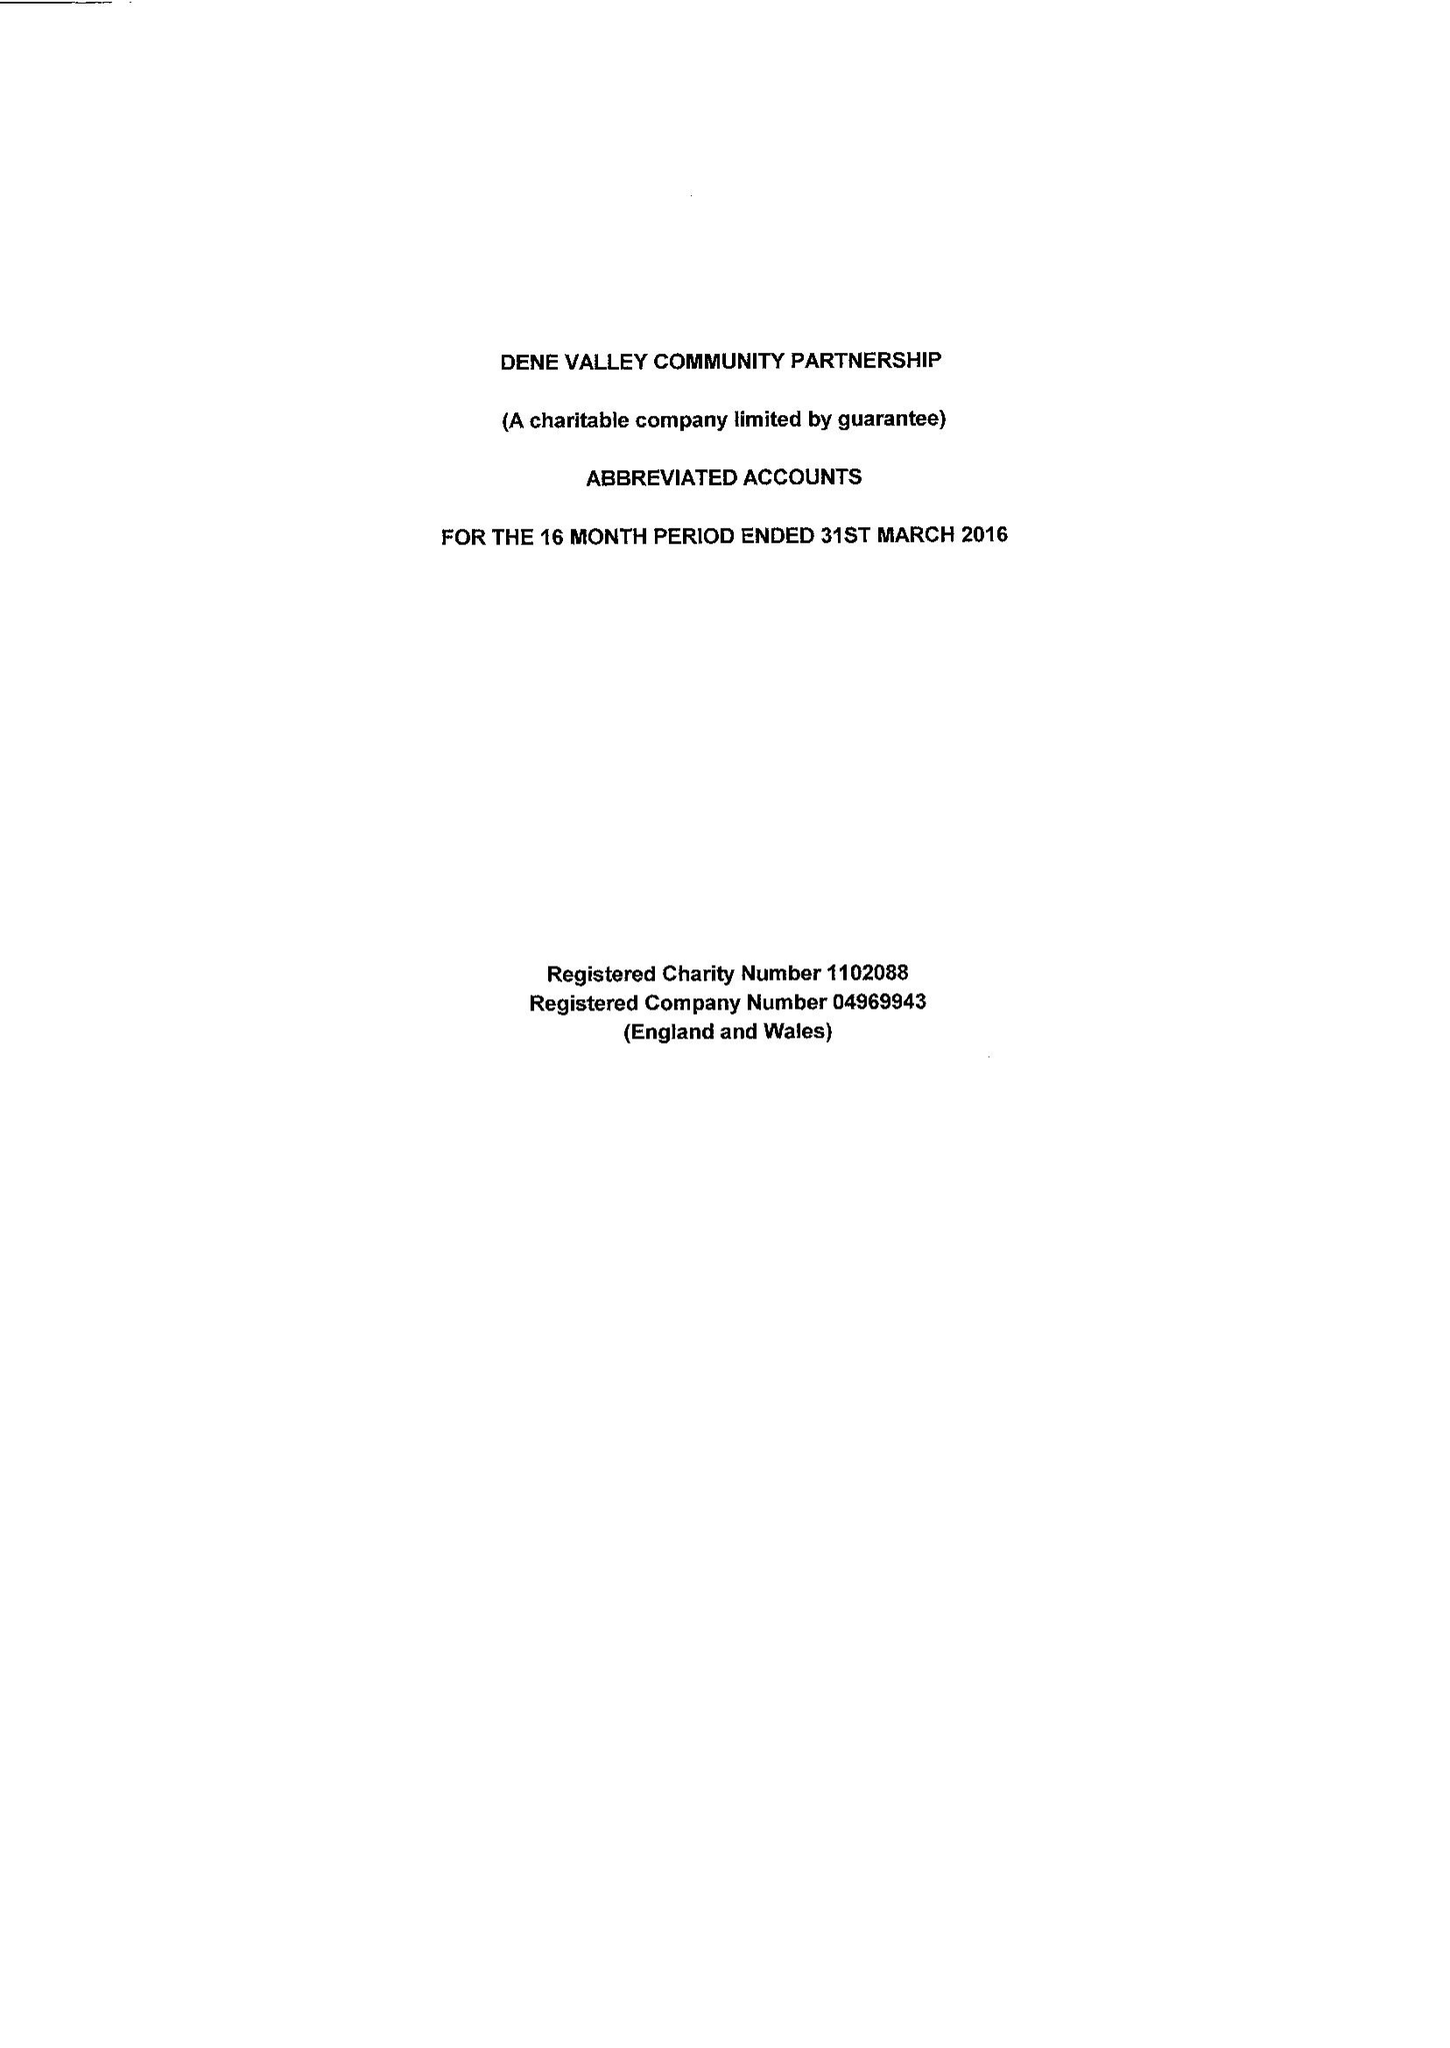What is the value for the report_date?
Answer the question using a single word or phrase. 2016-03-31 